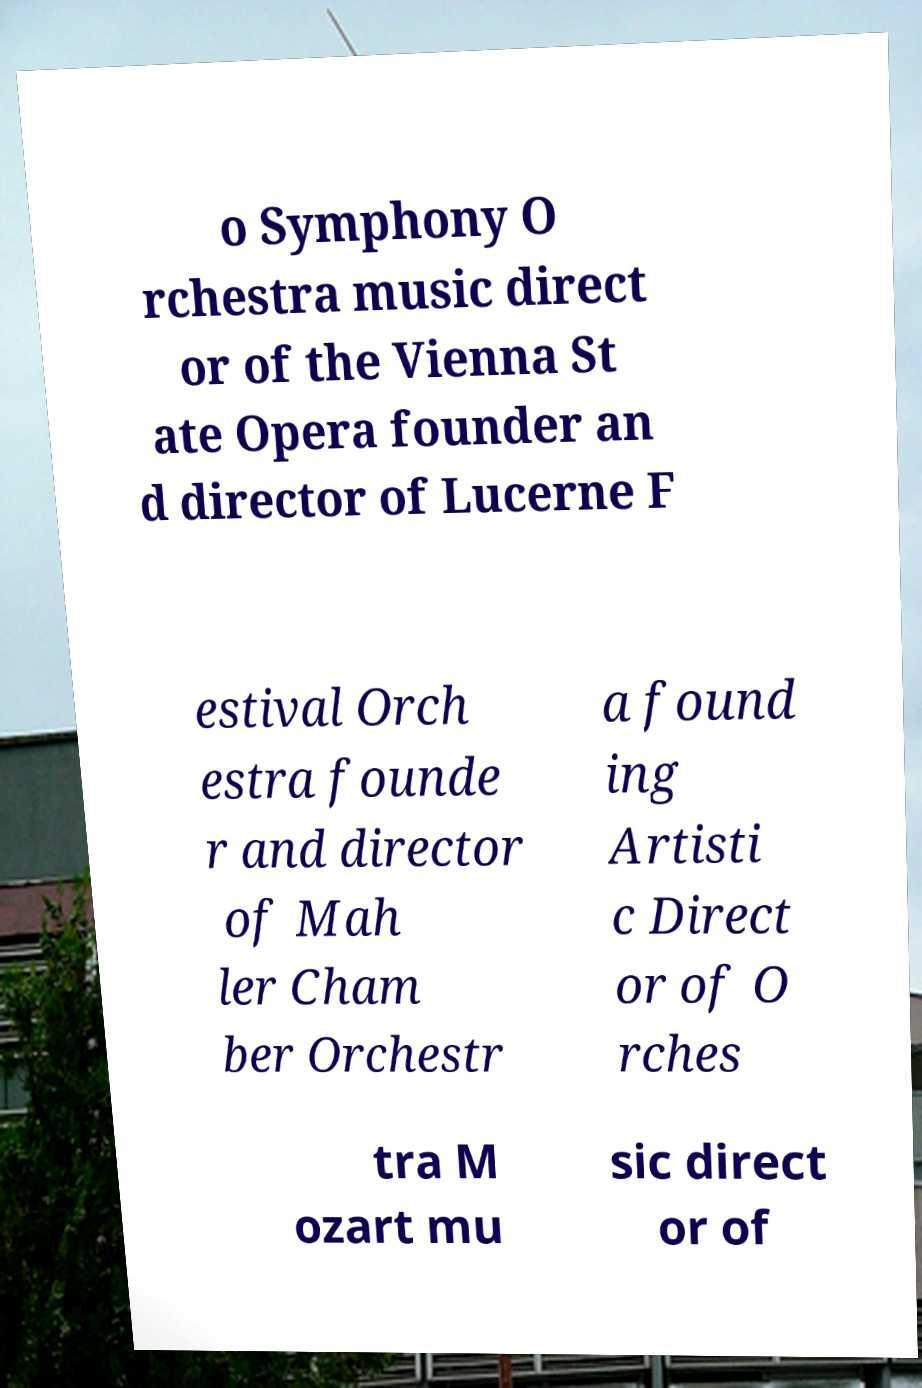For documentation purposes, I need the text within this image transcribed. Could you provide that? o Symphony O rchestra music direct or of the Vienna St ate Opera founder an d director of Lucerne F estival Orch estra founde r and director of Mah ler Cham ber Orchestr a found ing Artisti c Direct or of O rches tra M ozart mu sic direct or of 